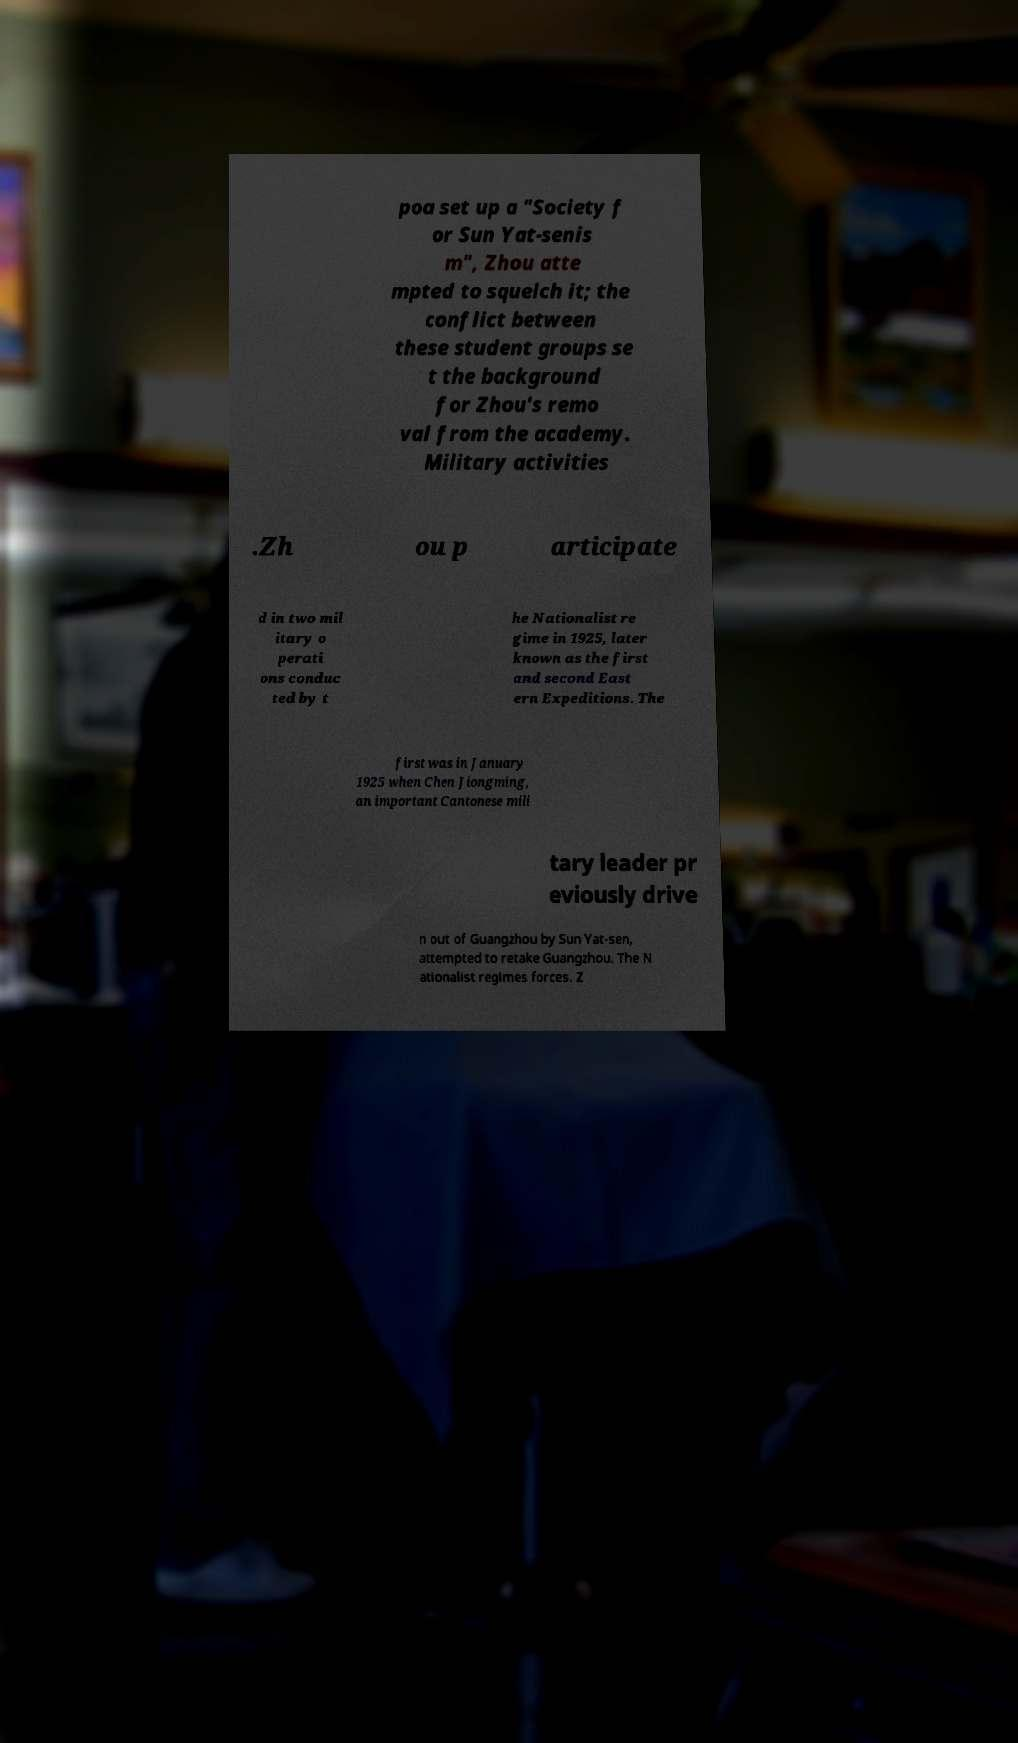Please read and relay the text visible in this image. What does it say? poa set up a "Society f or Sun Yat-senis m", Zhou atte mpted to squelch it; the conflict between these student groups se t the background for Zhou's remo val from the academy. Military activities .Zh ou p articipate d in two mil itary o perati ons conduc ted by t he Nationalist re gime in 1925, later known as the first and second East ern Expeditions. The first was in January 1925 when Chen Jiongming, an important Cantonese mili tary leader pr eviously drive n out of Guangzhou by Sun Yat-sen, attempted to retake Guangzhou. The N ationalist regimes forces. Z 